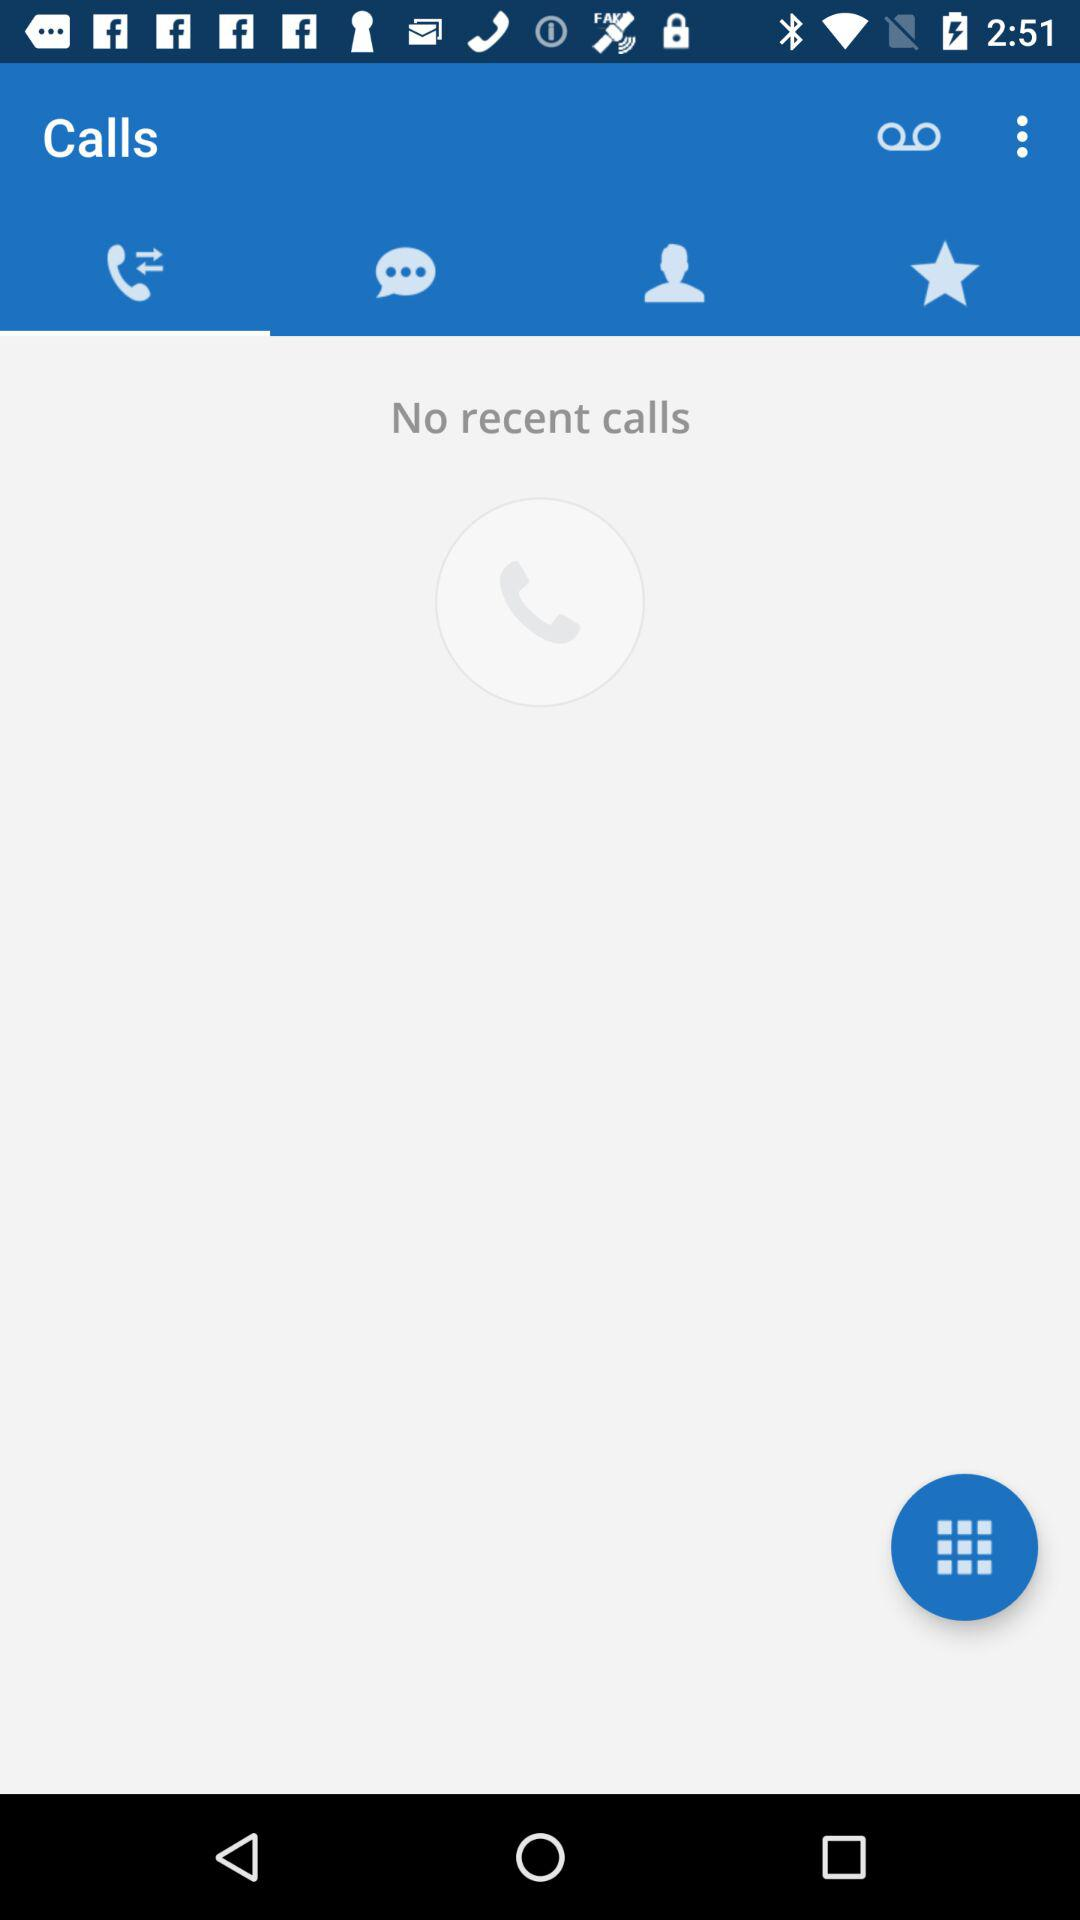Which tab is selected? The selected tab is "Recent". 